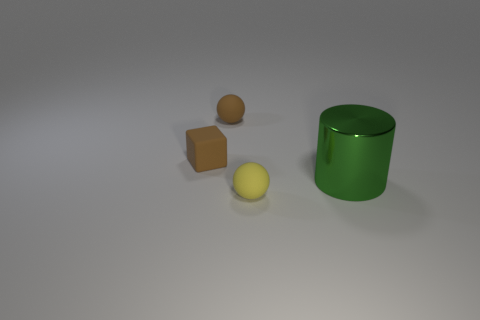Add 2 large gray metal balls. How many objects exist? 6 Subtract all cubes. How many objects are left? 3 Subtract 1 brown balls. How many objects are left? 3 Subtract all tiny brown matte balls. Subtract all large metal cylinders. How many objects are left? 2 Add 3 brown rubber cubes. How many brown rubber cubes are left? 4 Add 1 big cyan matte blocks. How many big cyan matte blocks exist? 1 